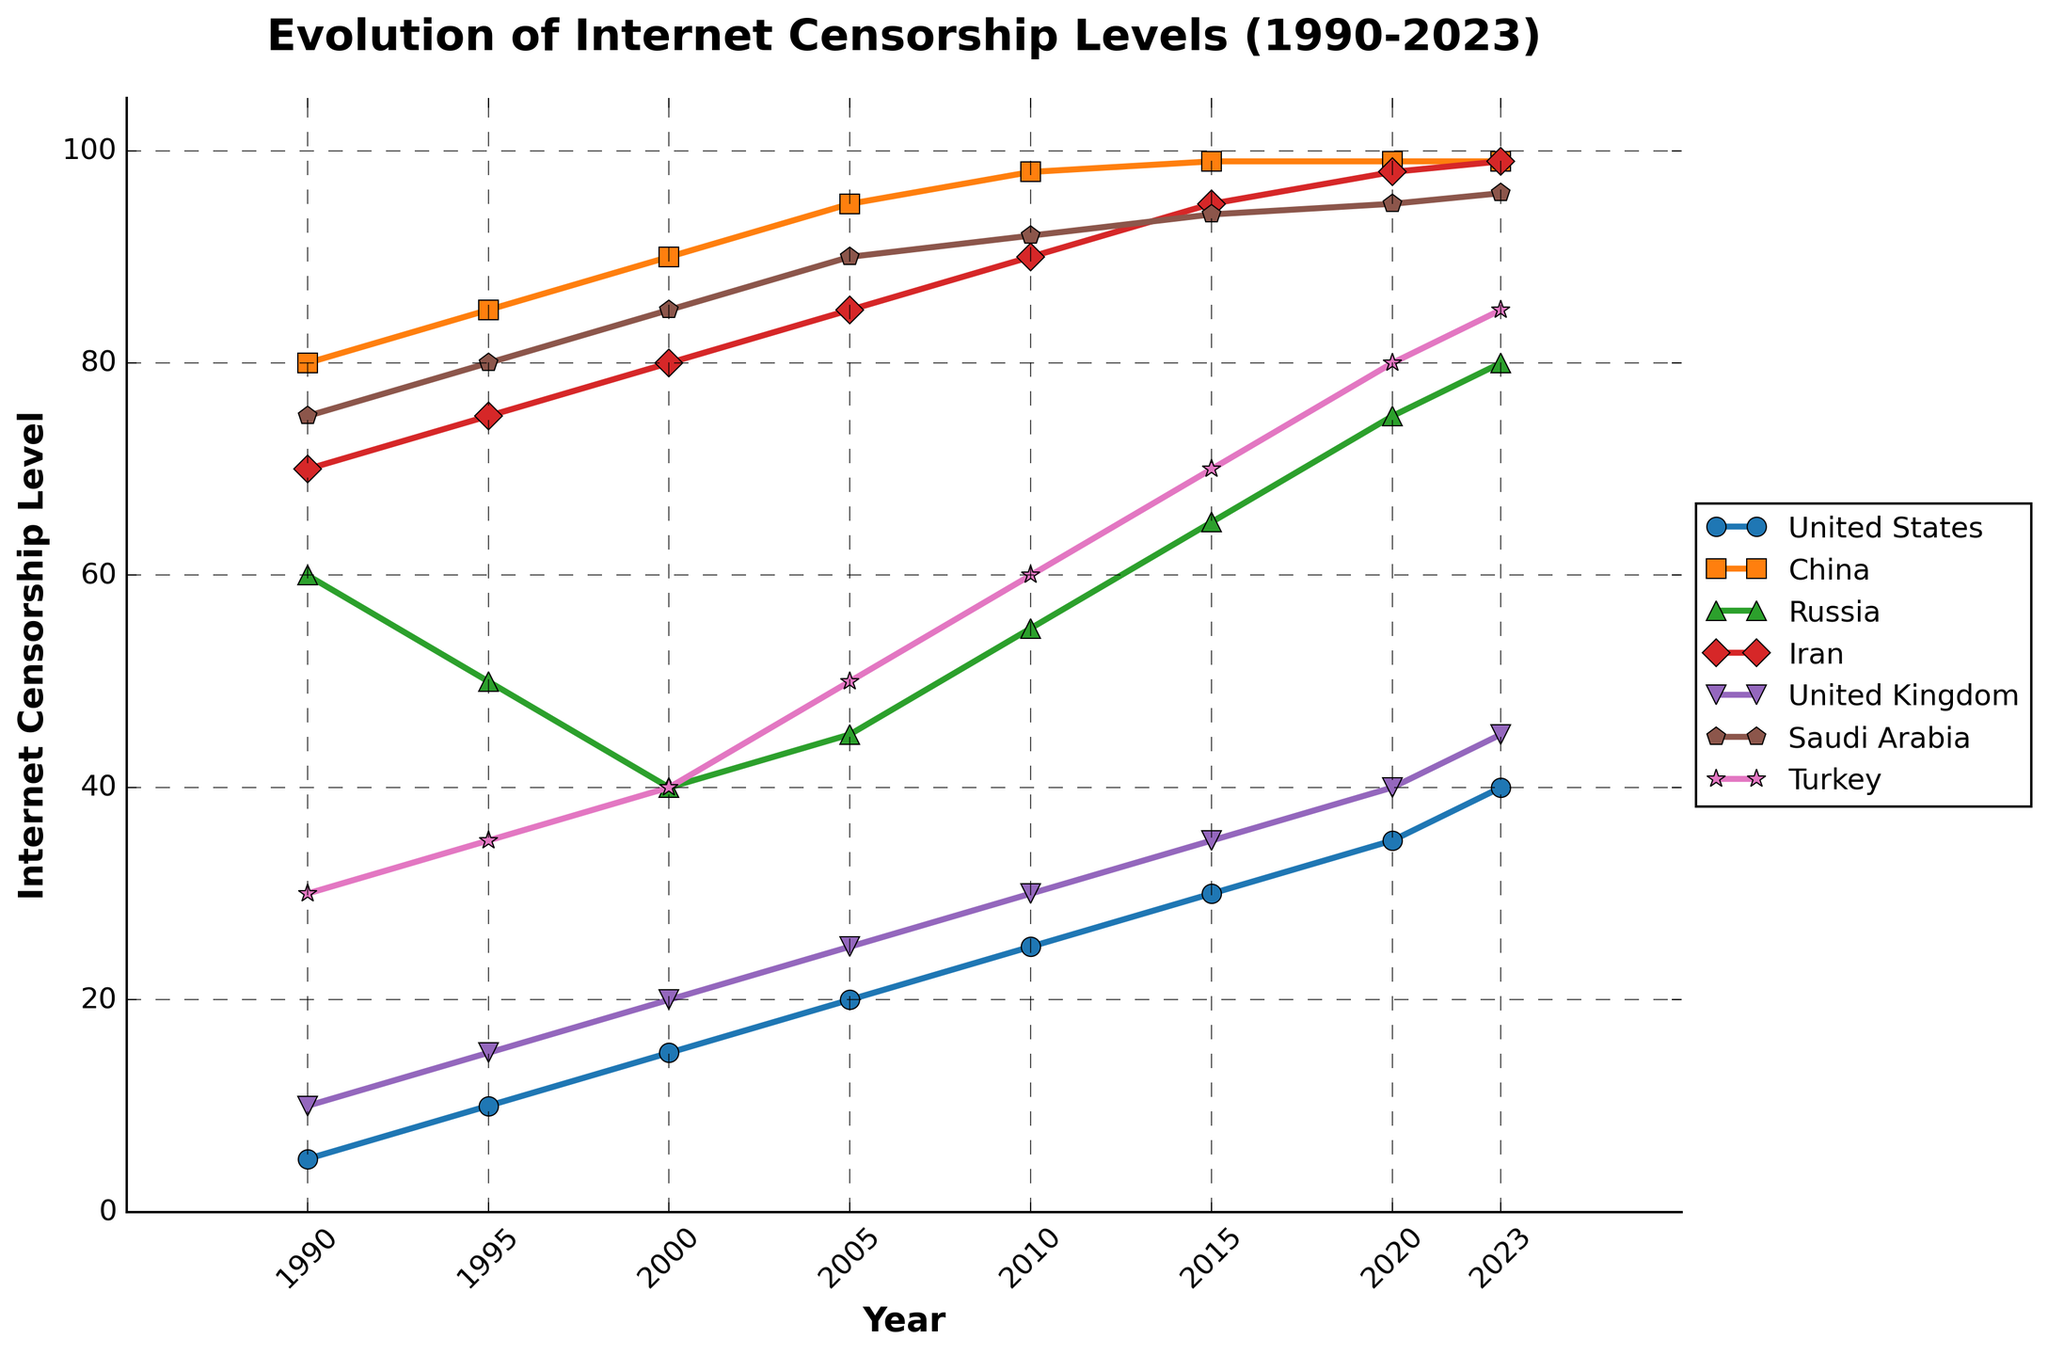When did China reach the maximum level of internet censorship shown on the graph? From the plot, observe that China's internet censorship levels are at the highest value of 99 from 2010 onwards.
Answer: 2010 Which country exhibited the most consistent increase in internet censorship from 1990 to 2023? By examining the trend lines, Saudi Arabia shows a consistent and steep increase from 75 in 1990 to 96 in 2023 without any dips.
Answer: Saudi Arabia How do the internet censorship levels in 1990 compare between the United Kingdom and Turkey? Refer to the starting point of both countries: The United Kingdom is at 10 and Turkey is at 30 in 1990.
Answer: Turkey is higher What is the difference in internet censorship levels between Russia and Iran in 2020? Reference the values for 2020: Russia is at 75 and Iran is at 98. Subtracting these gives: 98 - 75 = 23.
Answer: 23 Which country had the largest increase in censorship levels from 1995 to 2005? Calculate the increase: United States (20-10=10), China (95-85=10), Russia (45-50=-5), Iran (85-75=10), United Kingdom (25-15=10), Saudi Arabia (90-80=10), Turkey (50-35=15). Turkey increased the most by 15.
Answer: Turkey How many countries reached their peak censorship levels in 2023? Identify the highest points and note the year for each: United States (40 in 2023), China (99 in 2010), Russia (80 in 2023), Iran (99 in 2023), United Kingdom (45 in 2023), Saudi Arabia (96 in 2023), Turkey (85 in 2023). Count them: 6 countries peaked in 2023.
Answer: 6 Between 2000 and 2010, which country had the least fluctuation in their censorship levels? Compare the difference from 2000 to 2010: United States (25-15=10), China (98-90=8), Russia (55-40=15), Iran (90-80=10), United Kingdom (30-20=10), Saudi Arabia (92-85=7), Turkey (60-40=20). The smallest change is for Saudi Arabia, with a 7 unit increase.
Answer: Saudi Arabia Which country had a lower level of censorship than the United States in 1990, but a higher level than the United States in 2023? Compare United States in 1990 (5) and 2023 (40) with all countries. The United Kingdom had a lower level in 1990 (10 > 5) and higher in 2023 (45 > 40).
Answer: United Kingdom 